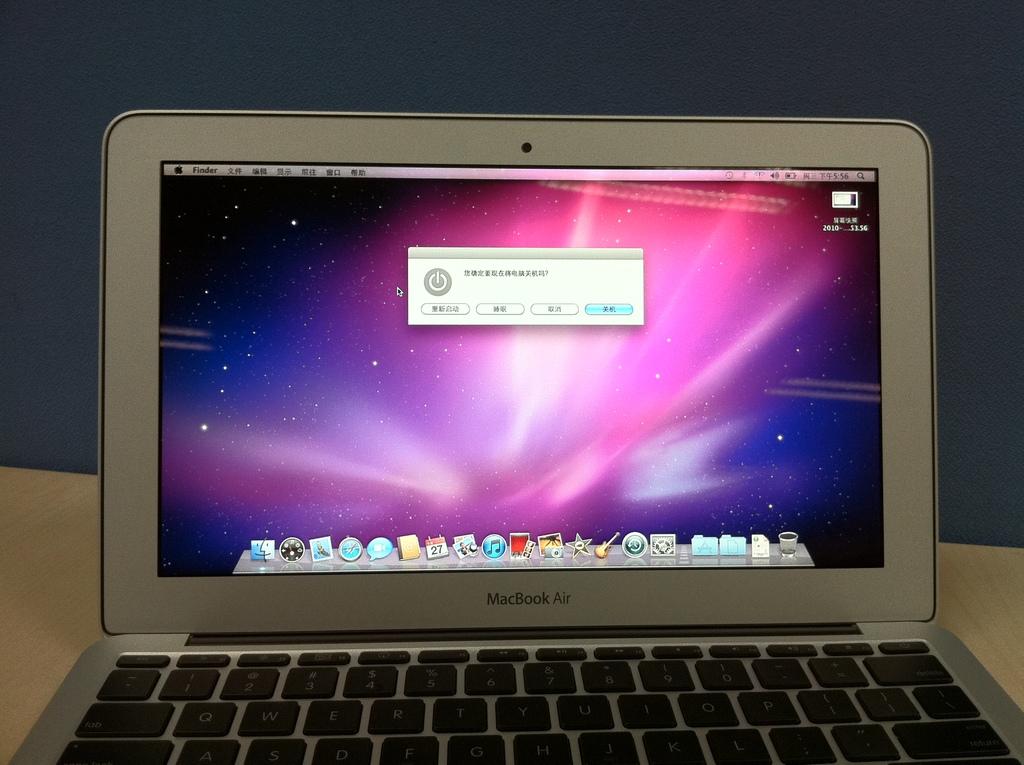What is the laptop brand?
Your answer should be very brief. Macbook air. 